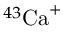Convert formula to latex. <formula><loc_0><loc_0><loc_500><loc_500>^ { 4 3 } { C a } ^ { + }</formula> 